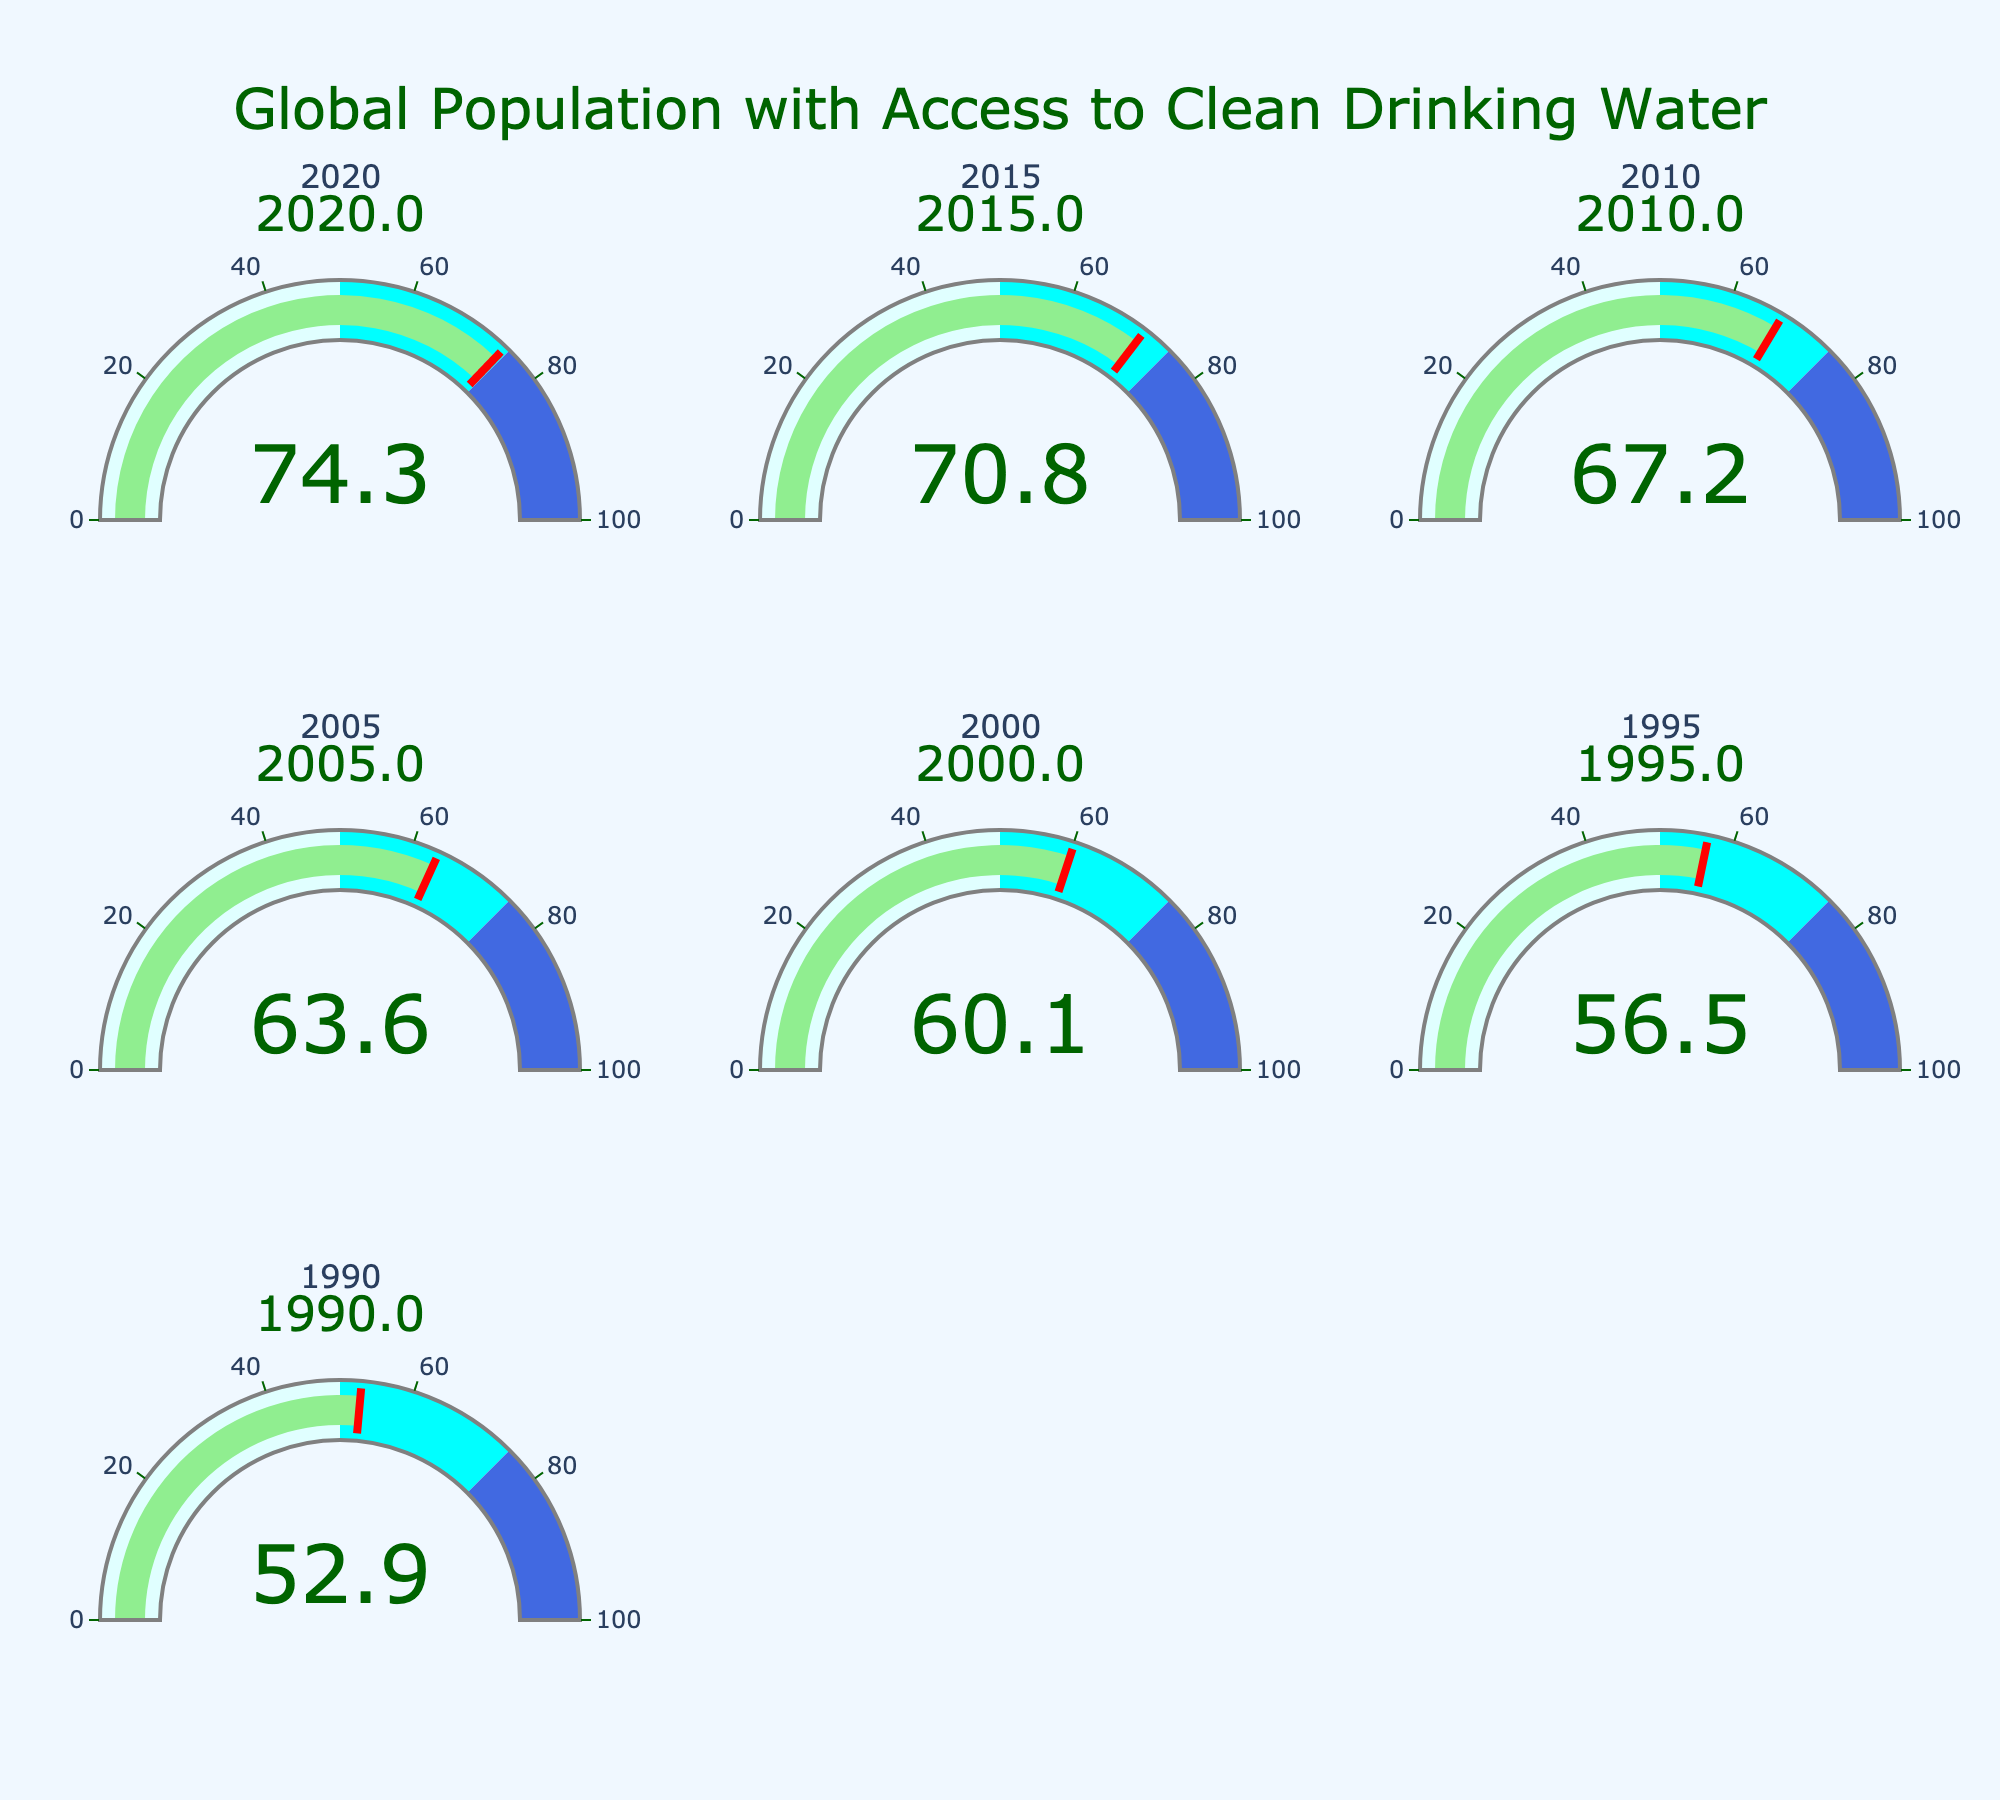What's the title of the figure? The title of the figure is prominently displayed at the top, stating the main topic it represents.
Answer: Global Population with Access to Clean Drinking Water How many years are represented in the figure? Based on the individual gauge charts, there are multiple subplots each titled with a year. Count these unique years.
Answer: 7 Which year has the highest global access percentage to clean drinking water? The figure has gauge charts for each year with numerical values displayed. Locate the year with the highest number.
Answer: 2020 What is the value of global access percentage in 1990? Find the gauge chart labeled with the year "1990" and read the value displayed on it.
Answer: 52.9% What is the increase in global access percentage from 1990 to 2020? Identify the values for 1990 and 2020, then subtract the 1990 value from the 2020 value to find the increase.
Answer: 21.4% Which year experienced the largest increase in global access percentage compared to the previous data point? Calculate the increase for each pair of consecutive years and identify the year with the largest difference.
Answer: 1995 to 2000 What is the average global access percentage over the years presented? Sum the access percentages for all the years and divide by the number of years to find the average. (74.3 + 70.8 + 67.2 + 63.6 + 60.1 + 56.5 + 52.9) / 7
Answer: 63.48% What color represents the range from 50 to 75 on the gauges? Each gauge has color-coded ranges. Locate the color corresponding to the specified range.
Answer: Cyan 